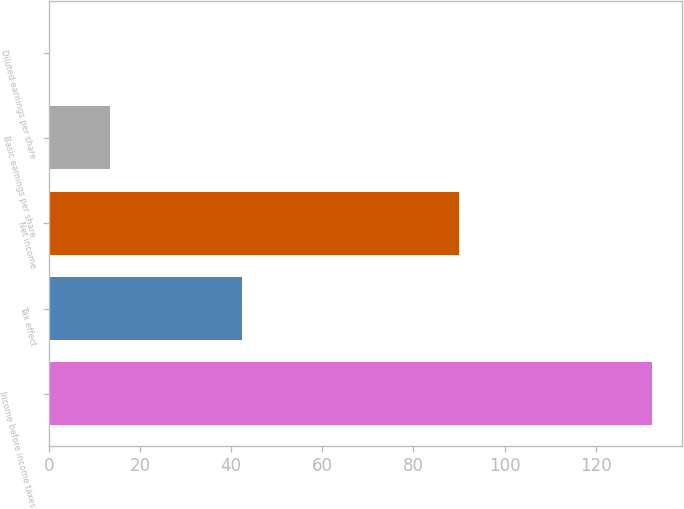<chart> <loc_0><loc_0><loc_500><loc_500><bar_chart><fcel>Income before income taxes<fcel>Tax effect<fcel>Net income<fcel>Basic earnings per share<fcel>Diluted earnings per share<nl><fcel>132.4<fcel>42.3<fcel>90.1<fcel>13.47<fcel>0.26<nl></chart> 